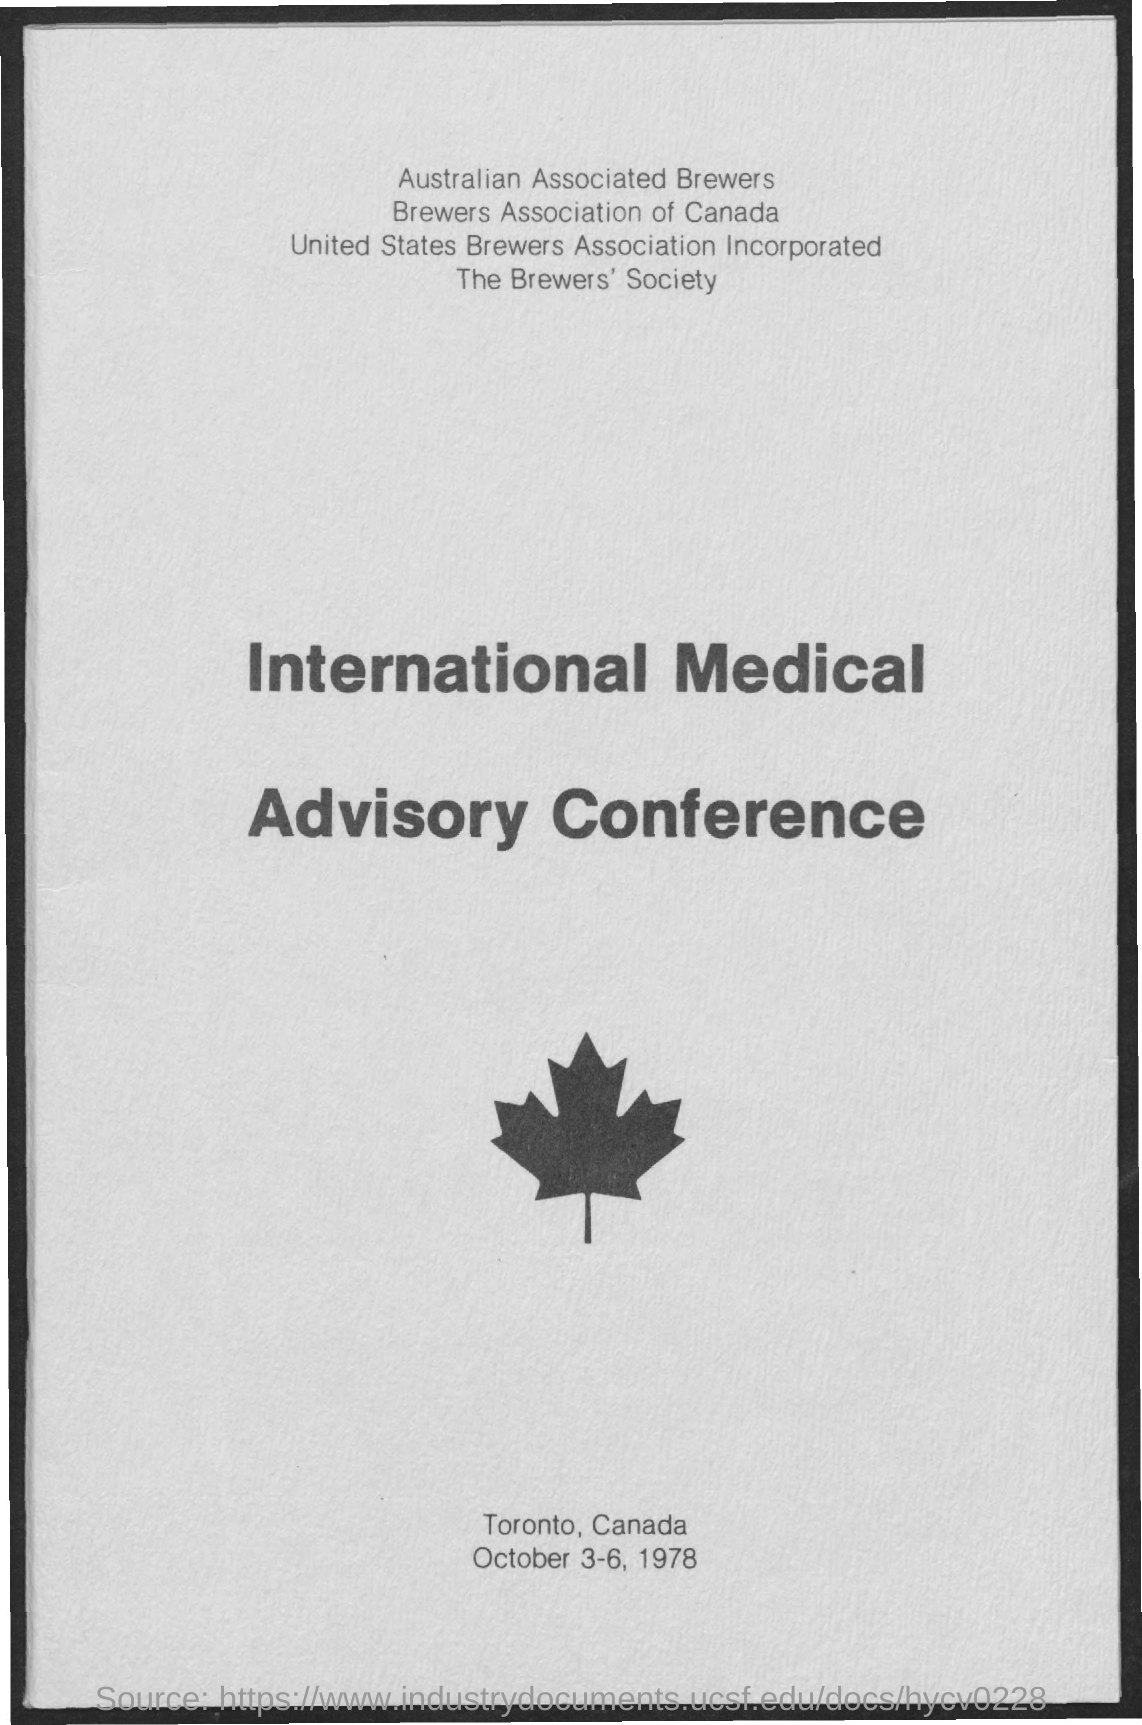What is the date mentioned ?
Your response must be concise. October 3-6 , 1978. What is the name of the society mentioned ?
Make the answer very short. The brewer's society. What is the name of the conference mentioned ?
Ensure brevity in your answer.  International medical advisory conference. 